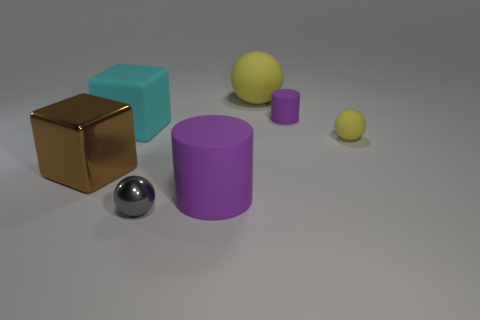Are the cube behind the big metallic cube and the big brown block made of the same material?
Provide a succinct answer. No. There is another object that is the same shape as the large brown shiny object; what is its color?
Provide a succinct answer. Cyan. Do the small sphere that is right of the gray sphere and the big rubber ball have the same color?
Your answer should be compact. Yes. The large thing that is the same color as the small cylinder is what shape?
Your answer should be compact. Cylinder. There is another ball that is the same color as the small rubber ball; what size is it?
Your answer should be compact. Large. How big is the rubber cylinder to the left of the yellow matte object that is left of the cylinder that is behind the large rubber cylinder?
Offer a terse response. Large. Are there any big matte cylinders on the left side of the block in front of the block on the right side of the brown metal object?
Your answer should be very brief. No. Are there more large purple things than large cubes?
Offer a terse response. No. The tiny ball in front of the small yellow matte thing is what color?
Your answer should be very brief. Gray. Is the number of cylinders that are left of the tiny gray metallic object greater than the number of balls?
Offer a very short reply. No. 